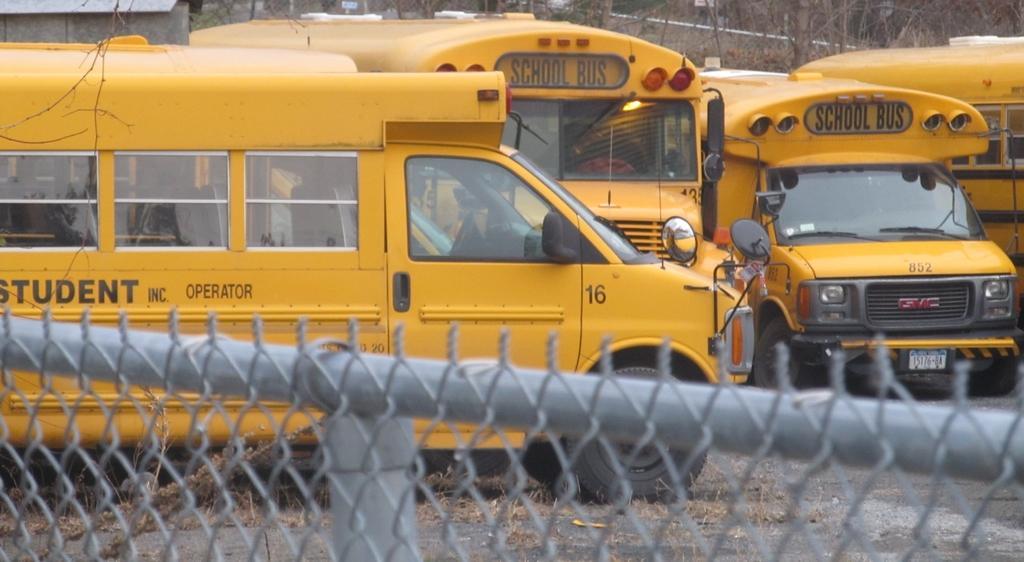Could you give a brief overview of what you see in this image? In the picture I can see yellow color vehicles on the ground. I can also see fence in front of the image. In the background I can see trees. 